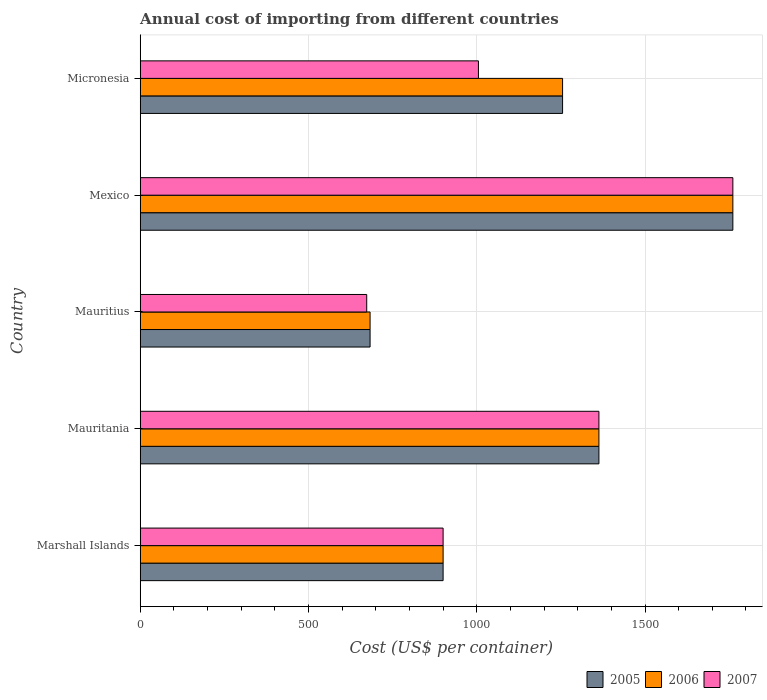How many groups of bars are there?
Your answer should be compact. 5. What is the label of the 5th group of bars from the top?
Give a very brief answer. Marshall Islands. What is the total annual cost of importing in 2007 in Micronesia?
Offer a terse response. 1005. Across all countries, what is the maximum total annual cost of importing in 2005?
Make the answer very short. 1761. Across all countries, what is the minimum total annual cost of importing in 2005?
Ensure brevity in your answer.  683. In which country was the total annual cost of importing in 2005 minimum?
Provide a short and direct response. Mauritius. What is the total total annual cost of importing in 2007 in the graph?
Your response must be concise. 5702. What is the difference between the total annual cost of importing in 2006 in Mauritius and that in Micronesia?
Offer a terse response. -572. What is the difference between the total annual cost of importing in 2006 in Marshall Islands and the total annual cost of importing in 2007 in Mauritania?
Your answer should be very brief. -463. What is the average total annual cost of importing in 2006 per country?
Keep it short and to the point. 1192.4. What is the difference between the total annual cost of importing in 2005 and total annual cost of importing in 2006 in Mexico?
Keep it short and to the point. 0. In how many countries, is the total annual cost of importing in 2006 greater than 1100 US$?
Provide a short and direct response. 3. What is the ratio of the total annual cost of importing in 2005 in Marshall Islands to that in Mexico?
Your answer should be compact. 0.51. Is the total annual cost of importing in 2006 in Mauritius less than that in Micronesia?
Make the answer very short. Yes. What is the difference between the highest and the second highest total annual cost of importing in 2007?
Provide a succinct answer. 398. What is the difference between the highest and the lowest total annual cost of importing in 2006?
Ensure brevity in your answer.  1078. Is the sum of the total annual cost of importing in 2005 in Mauritania and Mauritius greater than the maximum total annual cost of importing in 2007 across all countries?
Your response must be concise. Yes. What does the 1st bar from the top in Micronesia represents?
Ensure brevity in your answer.  2007. Is it the case that in every country, the sum of the total annual cost of importing in 2005 and total annual cost of importing in 2006 is greater than the total annual cost of importing in 2007?
Make the answer very short. Yes. How many bars are there?
Give a very brief answer. 15. Are all the bars in the graph horizontal?
Your answer should be compact. Yes. Does the graph contain any zero values?
Your answer should be compact. No. Where does the legend appear in the graph?
Provide a succinct answer. Bottom right. How many legend labels are there?
Offer a very short reply. 3. How are the legend labels stacked?
Offer a terse response. Horizontal. What is the title of the graph?
Ensure brevity in your answer.  Annual cost of importing from different countries. Does "1974" appear as one of the legend labels in the graph?
Your answer should be compact. No. What is the label or title of the X-axis?
Offer a very short reply. Cost (US$ per container). What is the label or title of the Y-axis?
Your answer should be very brief. Country. What is the Cost (US$ per container) of 2005 in Marshall Islands?
Provide a succinct answer. 900. What is the Cost (US$ per container) in 2006 in Marshall Islands?
Ensure brevity in your answer.  900. What is the Cost (US$ per container) in 2007 in Marshall Islands?
Your answer should be very brief. 900. What is the Cost (US$ per container) in 2005 in Mauritania?
Ensure brevity in your answer.  1363. What is the Cost (US$ per container) of 2006 in Mauritania?
Ensure brevity in your answer.  1363. What is the Cost (US$ per container) in 2007 in Mauritania?
Offer a terse response. 1363. What is the Cost (US$ per container) in 2005 in Mauritius?
Your answer should be very brief. 683. What is the Cost (US$ per container) in 2006 in Mauritius?
Ensure brevity in your answer.  683. What is the Cost (US$ per container) in 2007 in Mauritius?
Make the answer very short. 673. What is the Cost (US$ per container) in 2005 in Mexico?
Offer a terse response. 1761. What is the Cost (US$ per container) of 2006 in Mexico?
Your answer should be very brief. 1761. What is the Cost (US$ per container) in 2007 in Mexico?
Make the answer very short. 1761. What is the Cost (US$ per container) of 2005 in Micronesia?
Keep it short and to the point. 1255. What is the Cost (US$ per container) of 2006 in Micronesia?
Give a very brief answer. 1255. What is the Cost (US$ per container) of 2007 in Micronesia?
Keep it short and to the point. 1005. Across all countries, what is the maximum Cost (US$ per container) in 2005?
Provide a succinct answer. 1761. Across all countries, what is the maximum Cost (US$ per container) in 2006?
Give a very brief answer. 1761. Across all countries, what is the maximum Cost (US$ per container) in 2007?
Ensure brevity in your answer.  1761. Across all countries, what is the minimum Cost (US$ per container) of 2005?
Keep it short and to the point. 683. Across all countries, what is the minimum Cost (US$ per container) of 2006?
Offer a very short reply. 683. Across all countries, what is the minimum Cost (US$ per container) of 2007?
Make the answer very short. 673. What is the total Cost (US$ per container) in 2005 in the graph?
Provide a succinct answer. 5962. What is the total Cost (US$ per container) of 2006 in the graph?
Give a very brief answer. 5962. What is the total Cost (US$ per container) in 2007 in the graph?
Keep it short and to the point. 5702. What is the difference between the Cost (US$ per container) of 2005 in Marshall Islands and that in Mauritania?
Make the answer very short. -463. What is the difference between the Cost (US$ per container) in 2006 in Marshall Islands and that in Mauritania?
Keep it short and to the point. -463. What is the difference between the Cost (US$ per container) of 2007 in Marshall Islands and that in Mauritania?
Make the answer very short. -463. What is the difference between the Cost (US$ per container) in 2005 in Marshall Islands and that in Mauritius?
Provide a short and direct response. 217. What is the difference between the Cost (US$ per container) in 2006 in Marshall Islands and that in Mauritius?
Ensure brevity in your answer.  217. What is the difference between the Cost (US$ per container) in 2007 in Marshall Islands and that in Mauritius?
Make the answer very short. 227. What is the difference between the Cost (US$ per container) of 2005 in Marshall Islands and that in Mexico?
Provide a short and direct response. -861. What is the difference between the Cost (US$ per container) in 2006 in Marshall Islands and that in Mexico?
Your answer should be very brief. -861. What is the difference between the Cost (US$ per container) of 2007 in Marshall Islands and that in Mexico?
Provide a short and direct response. -861. What is the difference between the Cost (US$ per container) in 2005 in Marshall Islands and that in Micronesia?
Ensure brevity in your answer.  -355. What is the difference between the Cost (US$ per container) of 2006 in Marshall Islands and that in Micronesia?
Your answer should be compact. -355. What is the difference between the Cost (US$ per container) of 2007 in Marshall Islands and that in Micronesia?
Give a very brief answer. -105. What is the difference between the Cost (US$ per container) of 2005 in Mauritania and that in Mauritius?
Your answer should be compact. 680. What is the difference between the Cost (US$ per container) of 2006 in Mauritania and that in Mauritius?
Provide a succinct answer. 680. What is the difference between the Cost (US$ per container) of 2007 in Mauritania and that in Mauritius?
Your answer should be very brief. 690. What is the difference between the Cost (US$ per container) of 2005 in Mauritania and that in Mexico?
Provide a succinct answer. -398. What is the difference between the Cost (US$ per container) of 2006 in Mauritania and that in Mexico?
Your answer should be very brief. -398. What is the difference between the Cost (US$ per container) in 2007 in Mauritania and that in Mexico?
Ensure brevity in your answer.  -398. What is the difference between the Cost (US$ per container) in 2005 in Mauritania and that in Micronesia?
Ensure brevity in your answer.  108. What is the difference between the Cost (US$ per container) of 2006 in Mauritania and that in Micronesia?
Offer a very short reply. 108. What is the difference between the Cost (US$ per container) in 2007 in Mauritania and that in Micronesia?
Your answer should be compact. 358. What is the difference between the Cost (US$ per container) in 2005 in Mauritius and that in Mexico?
Offer a terse response. -1078. What is the difference between the Cost (US$ per container) in 2006 in Mauritius and that in Mexico?
Your response must be concise. -1078. What is the difference between the Cost (US$ per container) in 2007 in Mauritius and that in Mexico?
Offer a terse response. -1088. What is the difference between the Cost (US$ per container) of 2005 in Mauritius and that in Micronesia?
Give a very brief answer. -572. What is the difference between the Cost (US$ per container) of 2006 in Mauritius and that in Micronesia?
Your answer should be compact. -572. What is the difference between the Cost (US$ per container) of 2007 in Mauritius and that in Micronesia?
Provide a succinct answer. -332. What is the difference between the Cost (US$ per container) in 2005 in Mexico and that in Micronesia?
Your answer should be compact. 506. What is the difference between the Cost (US$ per container) of 2006 in Mexico and that in Micronesia?
Your answer should be compact. 506. What is the difference between the Cost (US$ per container) in 2007 in Mexico and that in Micronesia?
Make the answer very short. 756. What is the difference between the Cost (US$ per container) of 2005 in Marshall Islands and the Cost (US$ per container) of 2006 in Mauritania?
Provide a short and direct response. -463. What is the difference between the Cost (US$ per container) of 2005 in Marshall Islands and the Cost (US$ per container) of 2007 in Mauritania?
Offer a very short reply. -463. What is the difference between the Cost (US$ per container) of 2006 in Marshall Islands and the Cost (US$ per container) of 2007 in Mauritania?
Your answer should be compact. -463. What is the difference between the Cost (US$ per container) of 2005 in Marshall Islands and the Cost (US$ per container) of 2006 in Mauritius?
Give a very brief answer. 217. What is the difference between the Cost (US$ per container) in 2005 in Marshall Islands and the Cost (US$ per container) in 2007 in Mauritius?
Provide a short and direct response. 227. What is the difference between the Cost (US$ per container) in 2006 in Marshall Islands and the Cost (US$ per container) in 2007 in Mauritius?
Make the answer very short. 227. What is the difference between the Cost (US$ per container) in 2005 in Marshall Islands and the Cost (US$ per container) in 2006 in Mexico?
Provide a short and direct response. -861. What is the difference between the Cost (US$ per container) in 2005 in Marshall Islands and the Cost (US$ per container) in 2007 in Mexico?
Provide a short and direct response. -861. What is the difference between the Cost (US$ per container) of 2006 in Marshall Islands and the Cost (US$ per container) of 2007 in Mexico?
Make the answer very short. -861. What is the difference between the Cost (US$ per container) in 2005 in Marshall Islands and the Cost (US$ per container) in 2006 in Micronesia?
Provide a short and direct response. -355. What is the difference between the Cost (US$ per container) in 2005 in Marshall Islands and the Cost (US$ per container) in 2007 in Micronesia?
Offer a very short reply. -105. What is the difference between the Cost (US$ per container) in 2006 in Marshall Islands and the Cost (US$ per container) in 2007 in Micronesia?
Your answer should be very brief. -105. What is the difference between the Cost (US$ per container) of 2005 in Mauritania and the Cost (US$ per container) of 2006 in Mauritius?
Your answer should be compact. 680. What is the difference between the Cost (US$ per container) in 2005 in Mauritania and the Cost (US$ per container) in 2007 in Mauritius?
Ensure brevity in your answer.  690. What is the difference between the Cost (US$ per container) of 2006 in Mauritania and the Cost (US$ per container) of 2007 in Mauritius?
Your response must be concise. 690. What is the difference between the Cost (US$ per container) of 2005 in Mauritania and the Cost (US$ per container) of 2006 in Mexico?
Offer a terse response. -398. What is the difference between the Cost (US$ per container) in 2005 in Mauritania and the Cost (US$ per container) in 2007 in Mexico?
Provide a succinct answer. -398. What is the difference between the Cost (US$ per container) of 2006 in Mauritania and the Cost (US$ per container) of 2007 in Mexico?
Your response must be concise. -398. What is the difference between the Cost (US$ per container) in 2005 in Mauritania and the Cost (US$ per container) in 2006 in Micronesia?
Provide a short and direct response. 108. What is the difference between the Cost (US$ per container) of 2005 in Mauritania and the Cost (US$ per container) of 2007 in Micronesia?
Provide a short and direct response. 358. What is the difference between the Cost (US$ per container) of 2006 in Mauritania and the Cost (US$ per container) of 2007 in Micronesia?
Ensure brevity in your answer.  358. What is the difference between the Cost (US$ per container) of 2005 in Mauritius and the Cost (US$ per container) of 2006 in Mexico?
Your response must be concise. -1078. What is the difference between the Cost (US$ per container) in 2005 in Mauritius and the Cost (US$ per container) in 2007 in Mexico?
Keep it short and to the point. -1078. What is the difference between the Cost (US$ per container) of 2006 in Mauritius and the Cost (US$ per container) of 2007 in Mexico?
Offer a terse response. -1078. What is the difference between the Cost (US$ per container) in 2005 in Mauritius and the Cost (US$ per container) in 2006 in Micronesia?
Provide a short and direct response. -572. What is the difference between the Cost (US$ per container) in 2005 in Mauritius and the Cost (US$ per container) in 2007 in Micronesia?
Make the answer very short. -322. What is the difference between the Cost (US$ per container) in 2006 in Mauritius and the Cost (US$ per container) in 2007 in Micronesia?
Your answer should be compact. -322. What is the difference between the Cost (US$ per container) of 2005 in Mexico and the Cost (US$ per container) of 2006 in Micronesia?
Your response must be concise. 506. What is the difference between the Cost (US$ per container) in 2005 in Mexico and the Cost (US$ per container) in 2007 in Micronesia?
Offer a terse response. 756. What is the difference between the Cost (US$ per container) of 2006 in Mexico and the Cost (US$ per container) of 2007 in Micronesia?
Provide a short and direct response. 756. What is the average Cost (US$ per container) in 2005 per country?
Offer a terse response. 1192.4. What is the average Cost (US$ per container) in 2006 per country?
Keep it short and to the point. 1192.4. What is the average Cost (US$ per container) of 2007 per country?
Your answer should be very brief. 1140.4. What is the difference between the Cost (US$ per container) in 2005 and Cost (US$ per container) in 2007 in Marshall Islands?
Your answer should be compact. 0. What is the difference between the Cost (US$ per container) of 2006 and Cost (US$ per container) of 2007 in Marshall Islands?
Your response must be concise. 0. What is the difference between the Cost (US$ per container) in 2005 and Cost (US$ per container) in 2006 in Mauritania?
Your answer should be very brief. 0. What is the difference between the Cost (US$ per container) in 2005 and Cost (US$ per container) in 2007 in Mauritania?
Ensure brevity in your answer.  0. What is the difference between the Cost (US$ per container) of 2005 and Cost (US$ per container) of 2007 in Mauritius?
Offer a terse response. 10. What is the difference between the Cost (US$ per container) of 2005 and Cost (US$ per container) of 2006 in Mexico?
Your answer should be compact. 0. What is the difference between the Cost (US$ per container) in 2005 and Cost (US$ per container) in 2007 in Mexico?
Offer a very short reply. 0. What is the difference between the Cost (US$ per container) of 2006 and Cost (US$ per container) of 2007 in Mexico?
Offer a terse response. 0. What is the difference between the Cost (US$ per container) in 2005 and Cost (US$ per container) in 2007 in Micronesia?
Provide a short and direct response. 250. What is the difference between the Cost (US$ per container) of 2006 and Cost (US$ per container) of 2007 in Micronesia?
Give a very brief answer. 250. What is the ratio of the Cost (US$ per container) in 2005 in Marshall Islands to that in Mauritania?
Ensure brevity in your answer.  0.66. What is the ratio of the Cost (US$ per container) of 2006 in Marshall Islands to that in Mauritania?
Your response must be concise. 0.66. What is the ratio of the Cost (US$ per container) of 2007 in Marshall Islands to that in Mauritania?
Your response must be concise. 0.66. What is the ratio of the Cost (US$ per container) in 2005 in Marshall Islands to that in Mauritius?
Your answer should be very brief. 1.32. What is the ratio of the Cost (US$ per container) in 2006 in Marshall Islands to that in Mauritius?
Offer a very short reply. 1.32. What is the ratio of the Cost (US$ per container) of 2007 in Marshall Islands to that in Mauritius?
Provide a succinct answer. 1.34. What is the ratio of the Cost (US$ per container) in 2005 in Marshall Islands to that in Mexico?
Offer a very short reply. 0.51. What is the ratio of the Cost (US$ per container) of 2006 in Marshall Islands to that in Mexico?
Make the answer very short. 0.51. What is the ratio of the Cost (US$ per container) in 2007 in Marshall Islands to that in Mexico?
Make the answer very short. 0.51. What is the ratio of the Cost (US$ per container) in 2005 in Marshall Islands to that in Micronesia?
Offer a terse response. 0.72. What is the ratio of the Cost (US$ per container) in 2006 in Marshall Islands to that in Micronesia?
Offer a very short reply. 0.72. What is the ratio of the Cost (US$ per container) of 2007 in Marshall Islands to that in Micronesia?
Provide a short and direct response. 0.9. What is the ratio of the Cost (US$ per container) in 2005 in Mauritania to that in Mauritius?
Your answer should be compact. 2. What is the ratio of the Cost (US$ per container) in 2006 in Mauritania to that in Mauritius?
Ensure brevity in your answer.  2. What is the ratio of the Cost (US$ per container) in 2007 in Mauritania to that in Mauritius?
Ensure brevity in your answer.  2.03. What is the ratio of the Cost (US$ per container) in 2005 in Mauritania to that in Mexico?
Give a very brief answer. 0.77. What is the ratio of the Cost (US$ per container) in 2006 in Mauritania to that in Mexico?
Your answer should be compact. 0.77. What is the ratio of the Cost (US$ per container) of 2007 in Mauritania to that in Mexico?
Keep it short and to the point. 0.77. What is the ratio of the Cost (US$ per container) in 2005 in Mauritania to that in Micronesia?
Provide a short and direct response. 1.09. What is the ratio of the Cost (US$ per container) of 2006 in Mauritania to that in Micronesia?
Offer a very short reply. 1.09. What is the ratio of the Cost (US$ per container) of 2007 in Mauritania to that in Micronesia?
Keep it short and to the point. 1.36. What is the ratio of the Cost (US$ per container) of 2005 in Mauritius to that in Mexico?
Your answer should be compact. 0.39. What is the ratio of the Cost (US$ per container) in 2006 in Mauritius to that in Mexico?
Make the answer very short. 0.39. What is the ratio of the Cost (US$ per container) in 2007 in Mauritius to that in Mexico?
Provide a short and direct response. 0.38. What is the ratio of the Cost (US$ per container) of 2005 in Mauritius to that in Micronesia?
Make the answer very short. 0.54. What is the ratio of the Cost (US$ per container) of 2006 in Mauritius to that in Micronesia?
Ensure brevity in your answer.  0.54. What is the ratio of the Cost (US$ per container) of 2007 in Mauritius to that in Micronesia?
Keep it short and to the point. 0.67. What is the ratio of the Cost (US$ per container) of 2005 in Mexico to that in Micronesia?
Make the answer very short. 1.4. What is the ratio of the Cost (US$ per container) of 2006 in Mexico to that in Micronesia?
Your answer should be compact. 1.4. What is the ratio of the Cost (US$ per container) in 2007 in Mexico to that in Micronesia?
Ensure brevity in your answer.  1.75. What is the difference between the highest and the second highest Cost (US$ per container) of 2005?
Provide a succinct answer. 398. What is the difference between the highest and the second highest Cost (US$ per container) in 2006?
Give a very brief answer. 398. What is the difference between the highest and the second highest Cost (US$ per container) of 2007?
Offer a very short reply. 398. What is the difference between the highest and the lowest Cost (US$ per container) in 2005?
Provide a short and direct response. 1078. What is the difference between the highest and the lowest Cost (US$ per container) of 2006?
Your answer should be compact. 1078. What is the difference between the highest and the lowest Cost (US$ per container) in 2007?
Provide a succinct answer. 1088. 